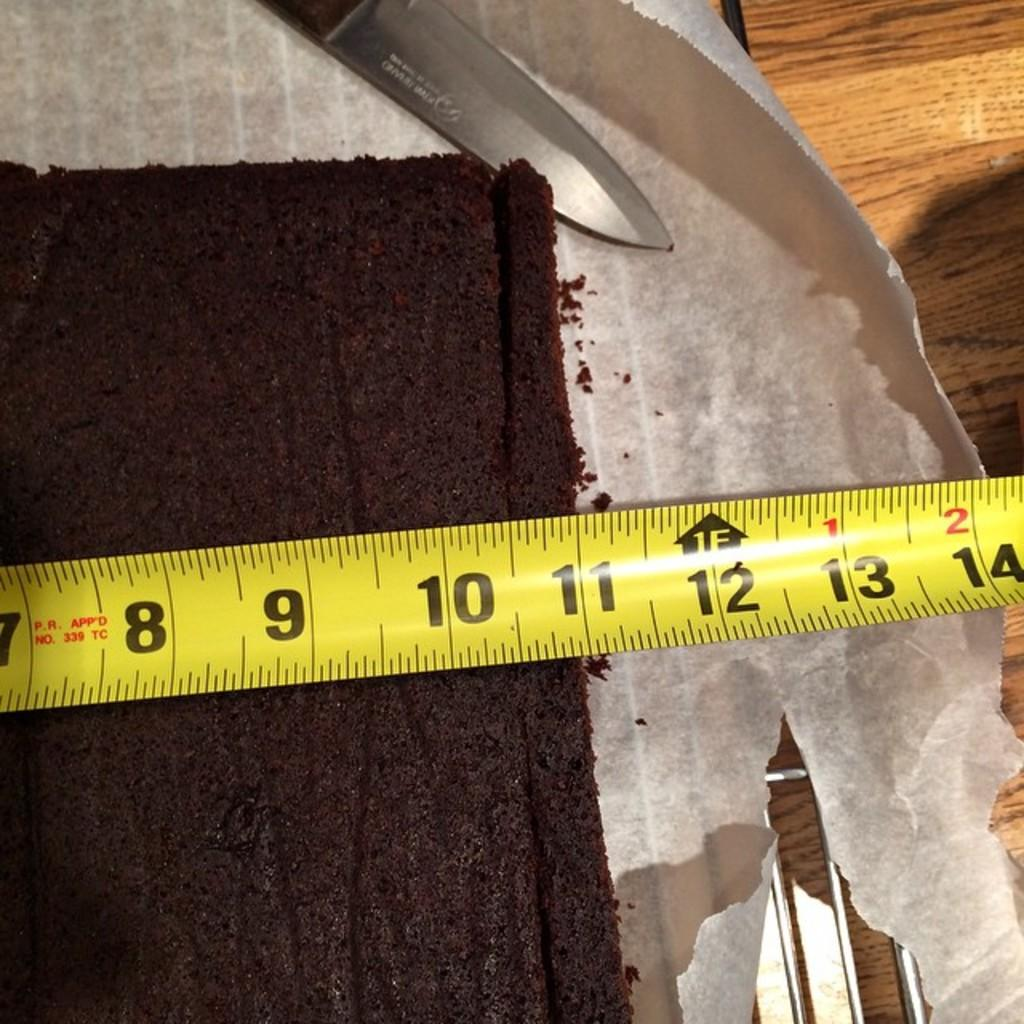Provide a one-sentence caption for the provided image. A tape measure showing a chocolate cake is 11" wide. 